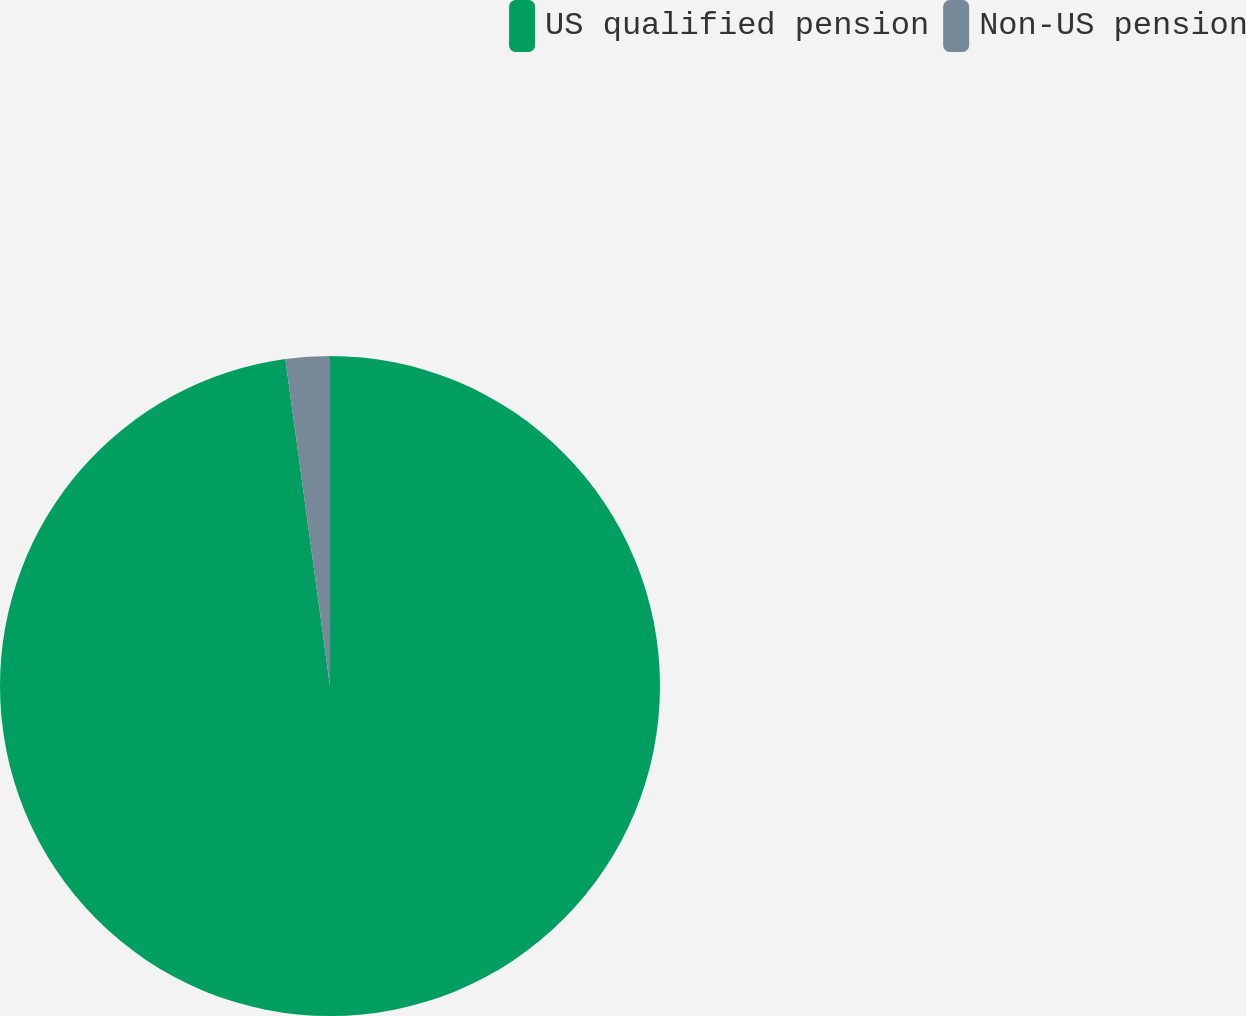Convert chart to OTSL. <chart><loc_0><loc_0><loc_500><loc_500><pie_chart><fcel>US qualified pension<fcel>Non-US pension<nl><fcel>97.84%<fcel>2.16%<nl></chart> 